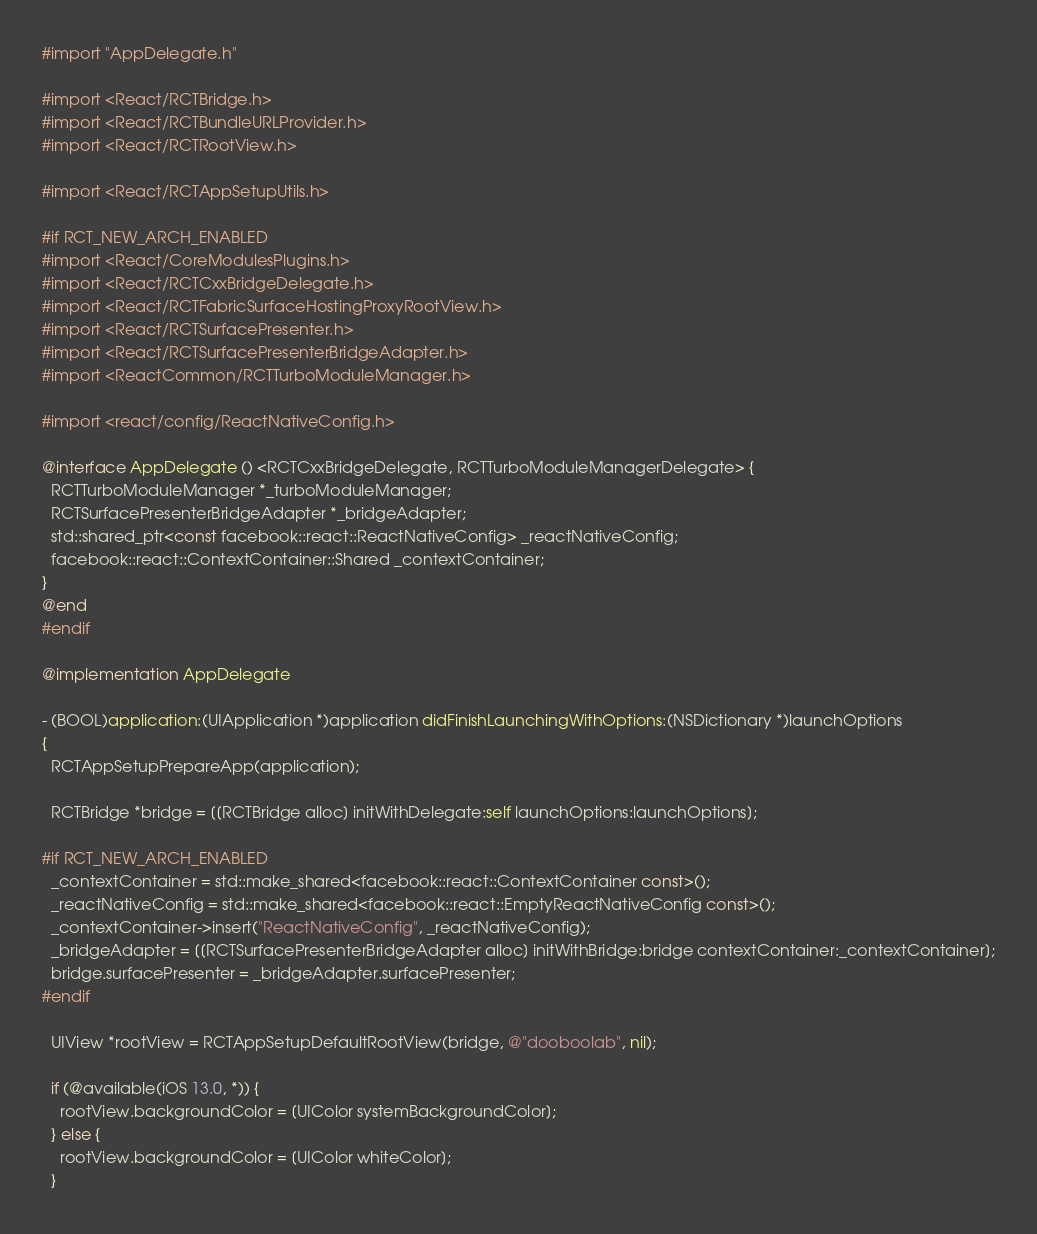Convert code to text. <code><loc_0><loc_0><loc_500><loc_500><_ObjectiveC_>#import "AppDelegate.h"

#import <React/RCTBridge.h>
#import <React/RCTBundleURLProvider.h>
#import <React/RCTRootView.h>

#import <React/RCTAppSetupUtils.h>

#if RCT_NEW_ARCH_ENABLED
#import <React/CoreModulesPlugins.h>
#import <React/RCTCxxBridgeDelegate.h>
#import <React/RCTFabricSurfaceHostingProxyRootView.h>
#import <React/RCTSurfacePresenter.h>
#import <React/RCTSurfacePresenterBridgeAdapter.h>
#import <ReactCommon/RCTTurboModuleManager.h>

#import <react/config/ReactNativeConfig.h>

@interface AppDelegate () <RCTCxxBridgeDelegate, RCTTurboModuleManagerDelegate> {
  RCTTurboModuleManager *_turboModuleManager;
  RCTSurfacePresenterBridgeAdapter *_bridgeAdapter;
  std::shared_ptr<const facebook::react::ReactNativeConfig> _reactNativeConfig;
  facebook::react::ContextContainer::Shared _contextContainer;
}
@end
#endif

@implementation AppDelegate

- (BOOL)application:(UIApplication *)application didFinishLaunchingWithOptions:(NSDictionary *)launchOptions
{
  RCTAppSetupPrepareApp(application);

  RCTBridge *bridge = [[RCTBridge alloc] initWithDelegate:self launchOptions:launchOptions];

#if RCT_NEW_ARCH_ENABLED
  _contextContainer = std::make_shared<facebook::react::ContextContainer const>();
  _reactNativeConfig = std::make_shared<facebook::react::EmptyReactNativeConfig const>();
  _contextContainer->insert("ReactNativeConfig", _reactNativeConfig);
  _bridgeAdapter = [[RCTSurfacePresenterBridgeAdapter alloc] initWithBridge:bridge contextContainer:_contextContainer];
  bridge.surfacePresenter = _bridgeAdapter.surfacePresenter;
#endif

  UIView *rootView = RCTAppSetupDefaultRootView(bridge, @"dooboolab", nil);

  if (@available(iOS 13.0, *)) {
    rootView.backgroundColor = [UIColor systemBackgroundColor];
  } else {
    rootView.backgroundColor = [UIColor whiteColor];
  }
</code> 